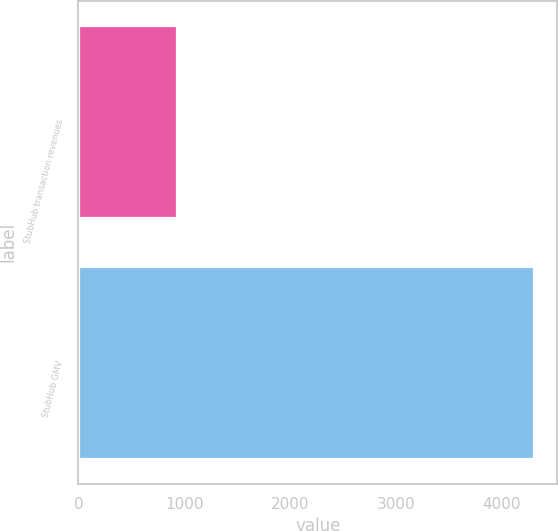<chart> <loc_0><loc_0><loc_500><loc_500><bar_chart><fcel>StubHub transaction revenues<fcel>StubHub GMV<nl><fcel>937<fcel>4310<nl></chart> 